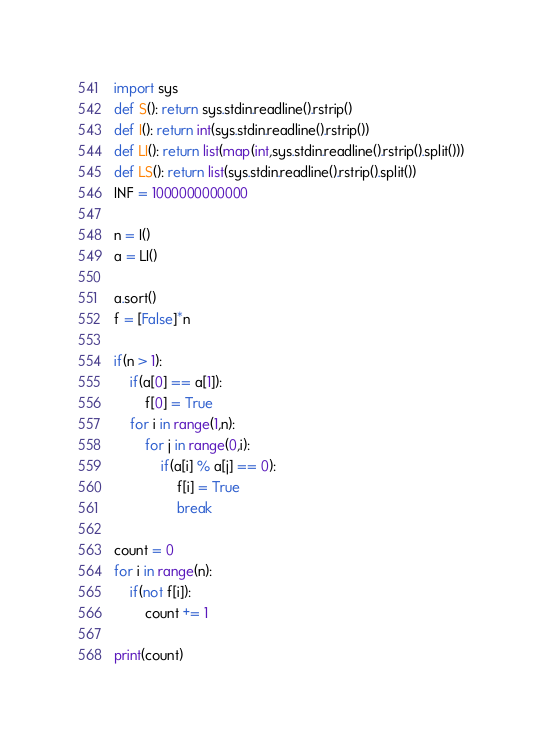Convert code to text. <code><loc_0><loc_0><loc_500><loc_500><_Python_>import sys
def S(): return sys.stdin.readline().rstrip()
def I(): return int(sys.stdin.readline().rstrip())
def LI(): return list(map(int,sys.stdin.readline().rstrip().split()))
def LS(): return list(sys.stdin.readline().rstrip().split())
INF = 1000000000000

n = I()
a = LI()

a.sort()
f = [False]*n

if(n > 1):
    if(a[0] == a[1]):
        f[0] = True
    for i in range(1,n):
        for j in range(0,i):
            if(a[i] % a[j] == 0):
                f[i] = True
                break

count = 0
for i in range(n):
    if(not f[i]):
        count += 1

print(count)</code> 